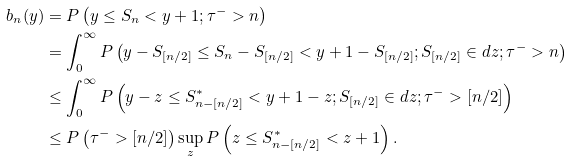Convert formula to latex. <formula><loc_0><loc_0><loc_500><loc_500>b _ { n } ( y ) & = P \left ( y \leq S _ { n } < y + 1 ; \tau ^ { - } > n \right ) \\ & = \int _ { 0 } ^ { \infty } P \left ( y - S _ { [ n / 2 ] } \leq S _ { n } - S _ { [ n / 2 ] } < y + 1 - S _ { [ n / 2 ] } ; S _ { [ n / 2 ] } \in d z ; \tau ^ { - } > n \right ) \\ & \leq \int _ { 0 } ^ { \infty } P \left ( y - z \leq S _ { n - [ n / 2 ] } ^ { \ast } < y + 1 - z ; S _ { [ n / 2 ] } \in d z ; \tau ^ { - } > [ n / 2 ] \right ) \\ & \leq P \left ( \tau ^ { - } > [ n / 2 ] \right ) \sup _ { z } P \left ( z \leq S _ { n - [ n / 2 ] } ^ { \ast } < z + 1 \right ) .</formula> 